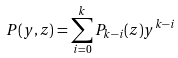Convert formula to latex. <formula><loc_0><loc_0><loc_500><loc_500>P ( y , z ) = \sum _ { i = 0 } ^ { k } P _ { k - i } ( z ) y ^ { k - i }</formula> 